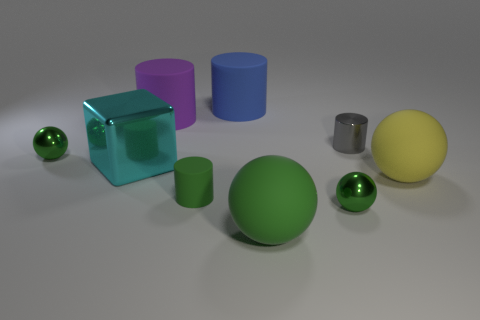There is a matte thing that is behind the purple cylinder; is its size the same as the large purple rubber object?
Make the answer very short. Yes. How big is the green object behind the yellow rubber object?
Offer a terse response. Small. Are there any other things that have the same material as the large green object?
Give a very brief answer. Yes. What number of large yellow blocks are there?
Offer a very short reply. 0. Does the metallic cube have the same color as the small rubber thing?
Offer a very short reply. No. What color is the small shiny object that is both left of the tiny gray cylinder and behind the cyan block?
Offer a terse response. Green. There is a tiny gray shiny object; are there any large yellow balls behind it?
Provide a succinct answer. No. There is a green shiny ball on the left side of the cyan metal thing; what number of big green balls are on the left side of it?
Your answer should be very brief. 0. What is the size of the green cylinder that is the same material as the big purple cylinder?
Provide a succinct answer. Small. The blue object is what size?
Offer a terse response. Large. 